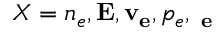<formula> <loc_0><loc_0><loc_500><loc_500>X = n _ { e } , { E } , { v _ { e } } , p _ { e } , { \Pi _ { e } }</formula> 